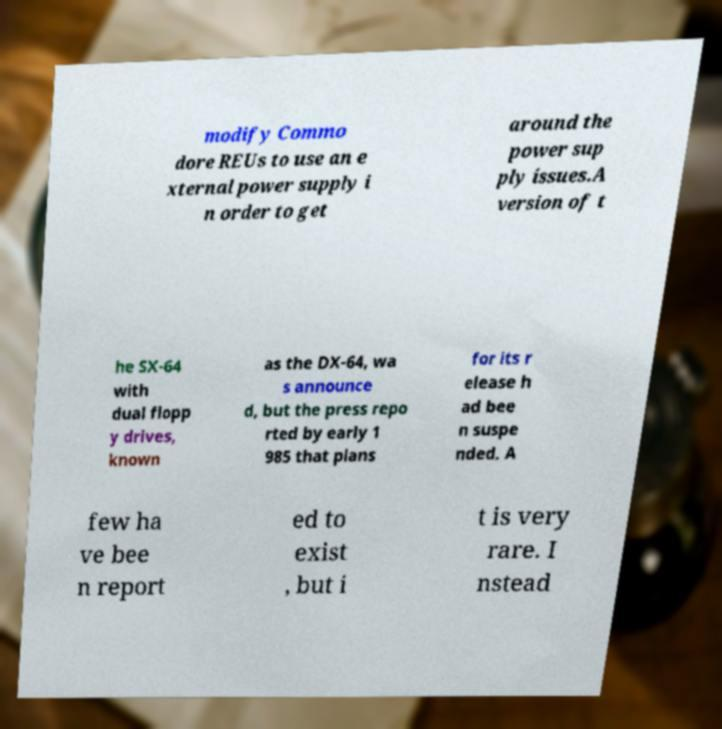Please identify and transcribe the text found in this image. modify Commo dore REUs to use an e xternal power supply i n order to get around the power sup ply issues.A version of t he SX-64 with dual flopp y drives, known as the DX-64, wa s announce d, but the press repo rted by early 1 985 that plans for its r elease h ad bee n suspe nded. A few ha ve bee n report ed to exist , but i t is very rare. I nstead 